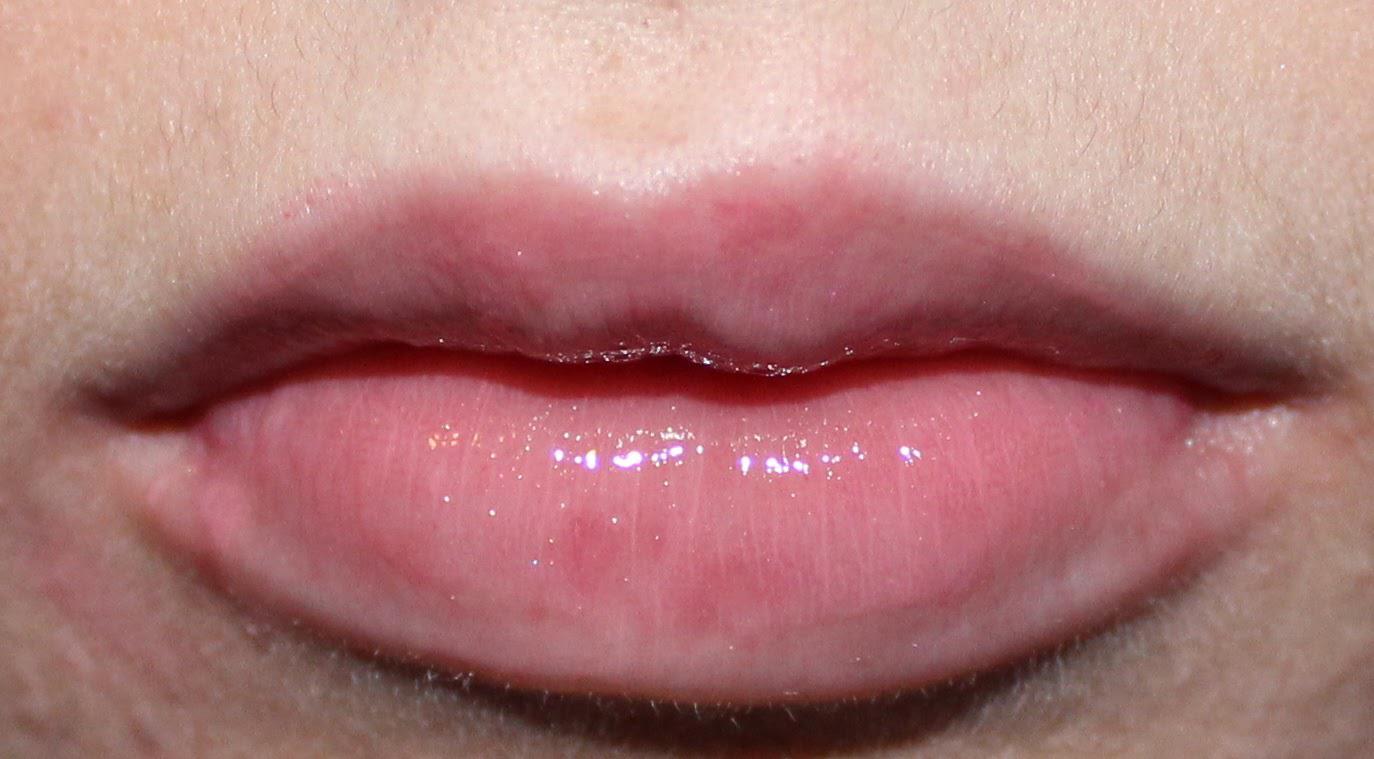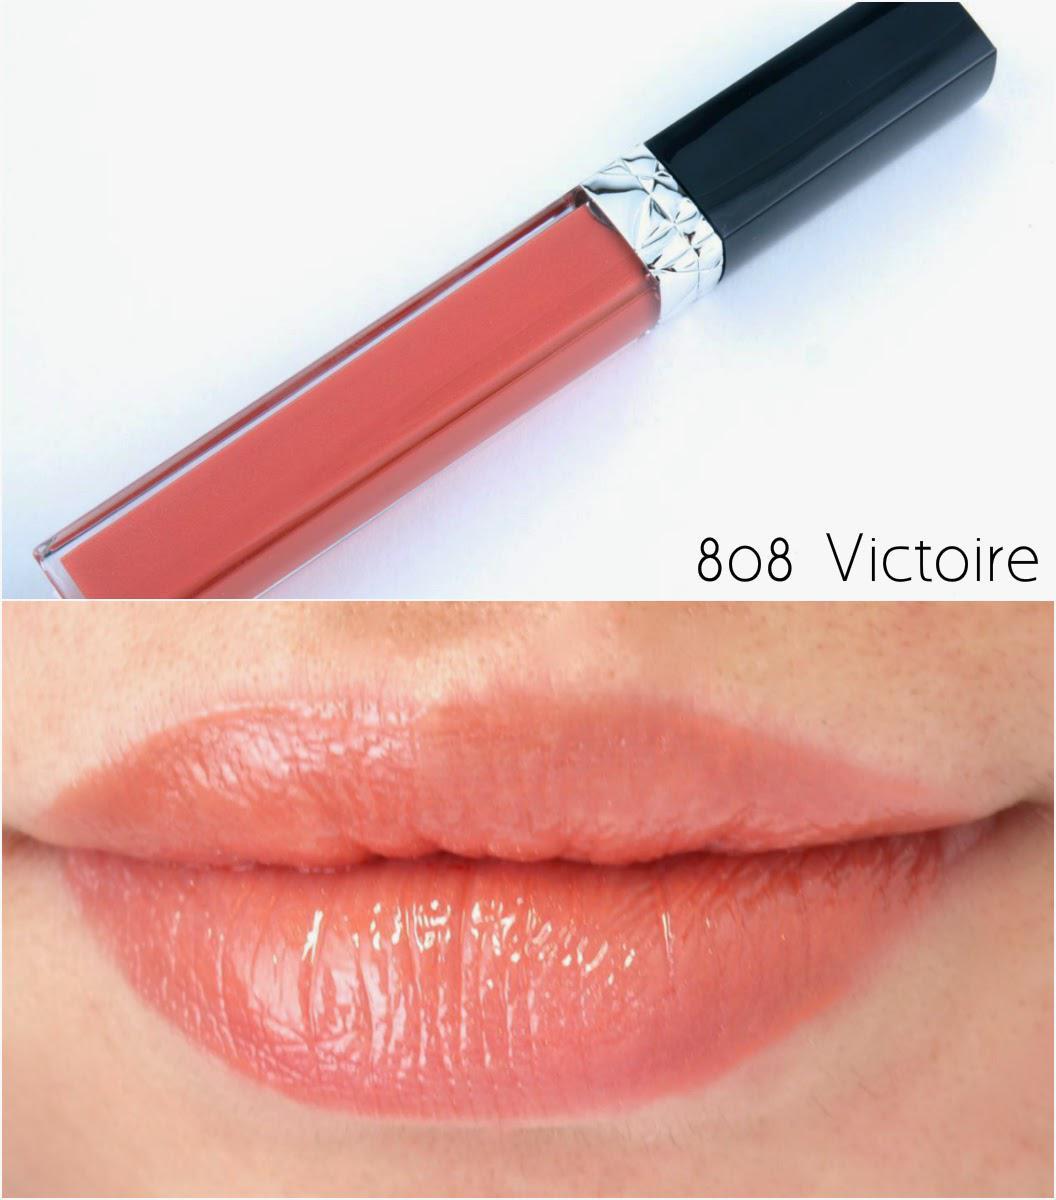The first image is the image on the left, the second image is the image on the right. For the images displayed, is the sentence "At least one of the images includes streaks of lip gloss on someone's skin." factually correct? Answer yes or no. No. The first image is the image on the left, the second image is the image on the right. Assess this claim about the two images: "Color swatches of lip products are on a person's skin.". Correct or not? Answer yes or no. No. 